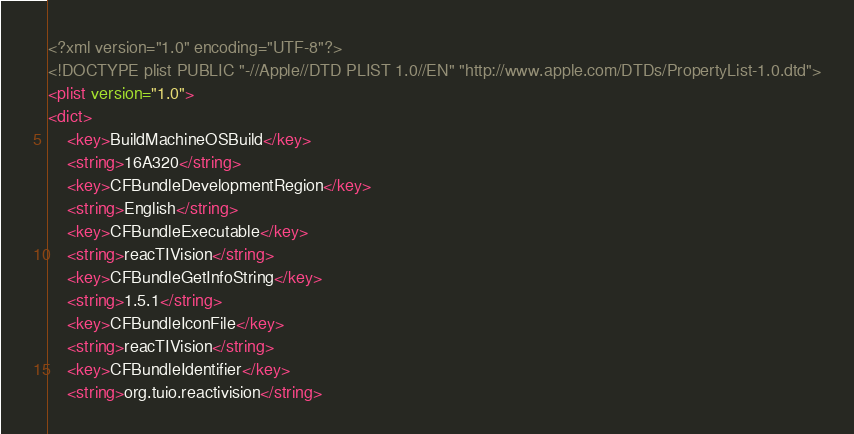Convert code to text. <code><loc_0><loc_0><loc_500><loc_500><_XML_><?xml version="1.0" encoding="UTF-8"?>
<!DOCTYPE plist PUBLIC "-//Apple//DTD PLIST 1.0//EN" "http://www.apple.com/DTDs/PropertyList-1.0.dtd">
<plist version="1.0">
<dict>
	<key>BuildMachineOSBuild</key>
	<string>16A320</string>
	<key>CFBundleDevelopmentRegion</key>
	<string>English</string>
	<key>CFBundleExecutable</key>
	<string>reacTIVision</string>
	<key>CFBundleGetInfoString</key>
	<string>1.5.1</string>
	<key>CFBundleIconFile</key>
	<string>reacTIVision</string>
	<key>CFBundleIdentifier</key>
	<string>org.tuio.reactivision</string></code> 